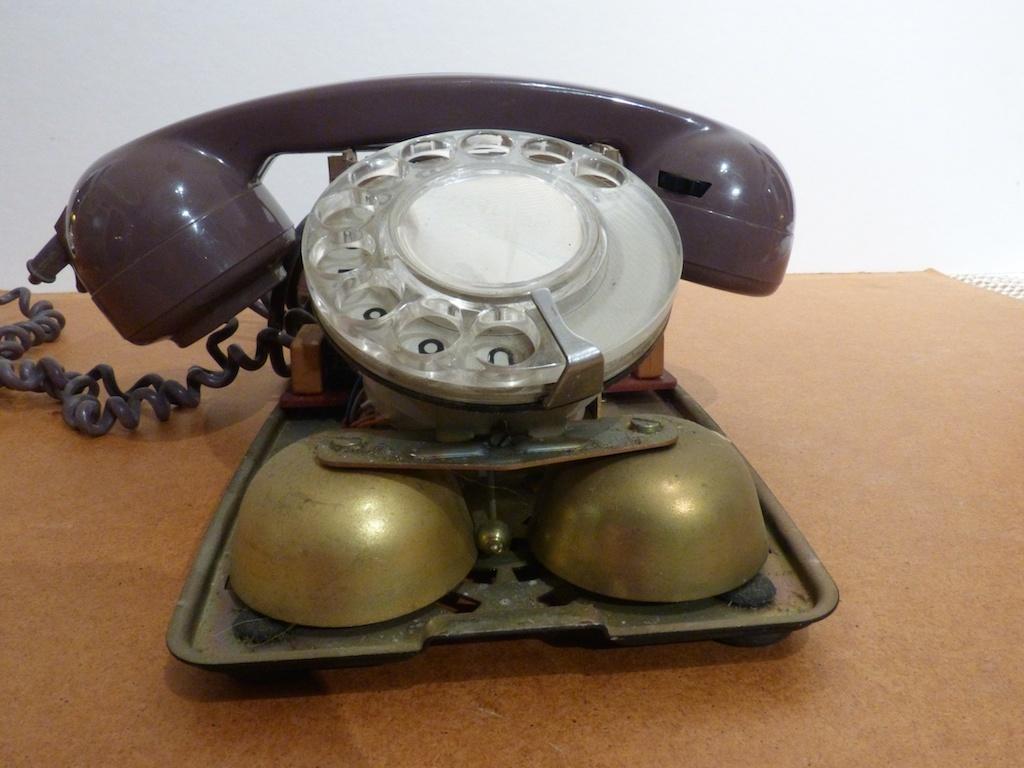Could you give a brief overview of what you see in this image? In this image I can see an old telephone and there are two bells in gold color to this, on a wooden board. 